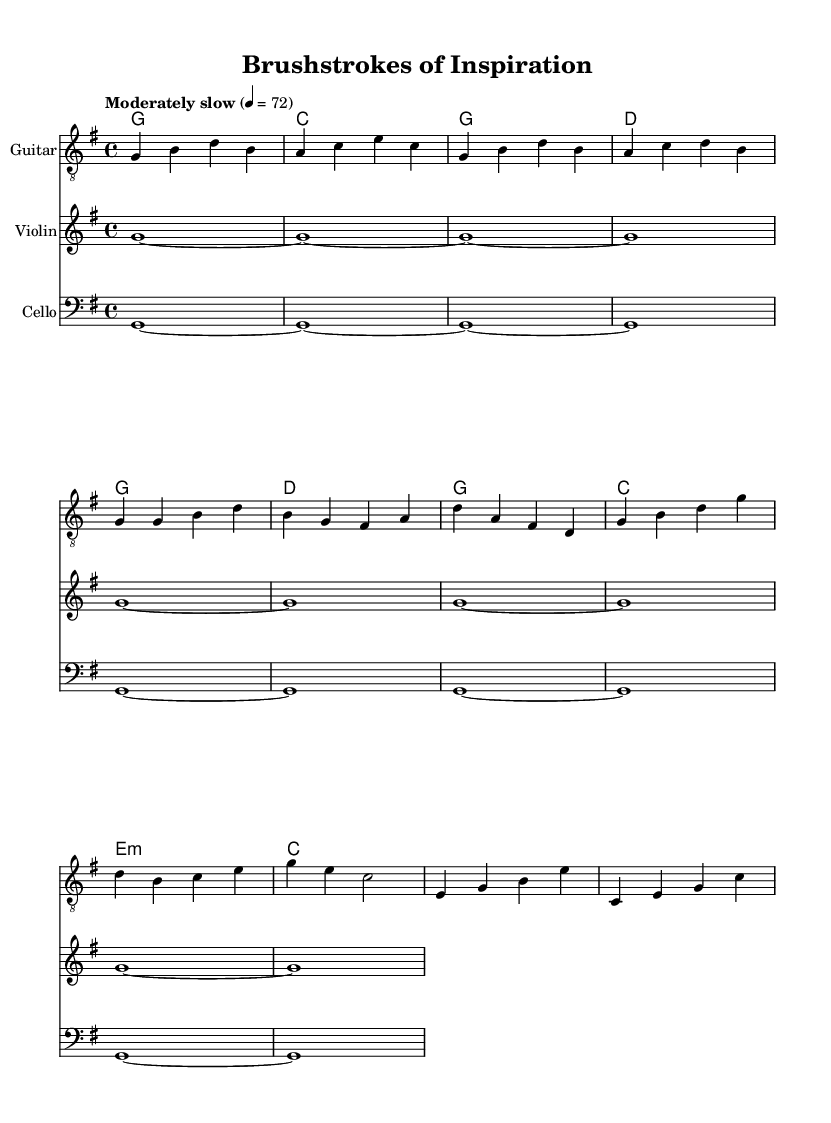What is the key signature of this music? The key signature is G major, which has one sharp (F#). This can be determined from the global block where the instruction "\key g \major" indicates the key.
Answer: G major What is the time signature of this piece? The time signature is 4/4, which is indicated in the global block with "\time 4/4". This means there are four beats in each measure and the quarter note receives one beat.
Answer: 4/4 What is the tempo marking for this composition? The tempo marking is "Moderately slow" with the rate of 72 beats per minute. This is specified in the global section with "\tempo 'Moderately slow' 4 = 72".
Answer: Moderately slow What is the instrument primarily featured in the piece? The primary instrument featured in the sheet music is the Guitar, as it is the first staff and includes guitar-specific notations such as the tab-clef.
Answer: Guitar Which chord is played at the end of the first measure? The chord played at the end of the first measure is G major, as seen in the chord progression where the first chord listed is "g1" in the chord mode.
Answer: G How many measures are present in the guitar music excerpt? There are 8 measures present in the guitar music excerpt. This is determined by counting the measures in the relative chord progression and guitar notation, as indicated by the sequence of notes and bars.
Answer: 8 What is the thematic focus of this piece? The thematic focus of this piece revolves around creativity and artistic expression, found in the title "Brushstrokes of Inspiration" and the overall style of contemporary indie folk.
Answer: Creativity and artistic expression 